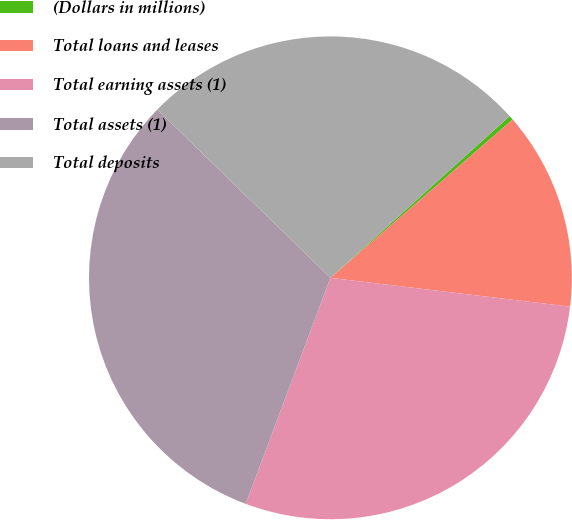<chart> <loc_0><loc_0><loc_500><loc_500><pie_chart><fcel>(Dollars in millions)<fcel>Total loans and leases<fcel>Total earning assets (1)<fcel>Total assets (1)<fcel>Total deposits<nl><fcel>0.3%<fcel>13.29%<fcel>28.8%<fcel>31.57%<fcel>26.04%<nl></chart> 